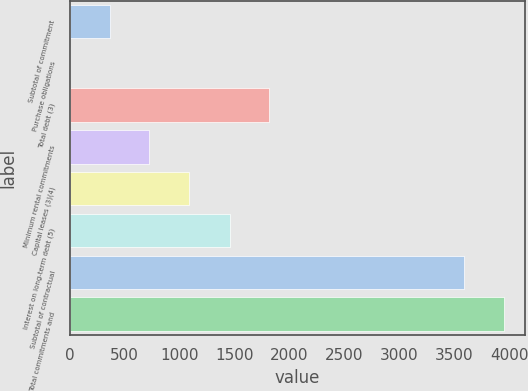Convert chart to OTSL. <chart><loc_0><loc_0><loc_500><loc_500><bar_chart><fcel>Subtotal of commitment<fcel>Purchase obligations<fcel>Total debt (3)<fcel>Minimum rental commitments<fcel>Capital leases (3)(4)<fcel>Interest on long-term debt (5)<fcel>Subtotal of contractual<fcel>Total commitments and<nl><fcel>364.6<fcel>3<fcel>1817.6<fcel>726.2<fcel>1087.8<fcel>1456<fcel>3590<fcel>3951.6<nl></chart> 